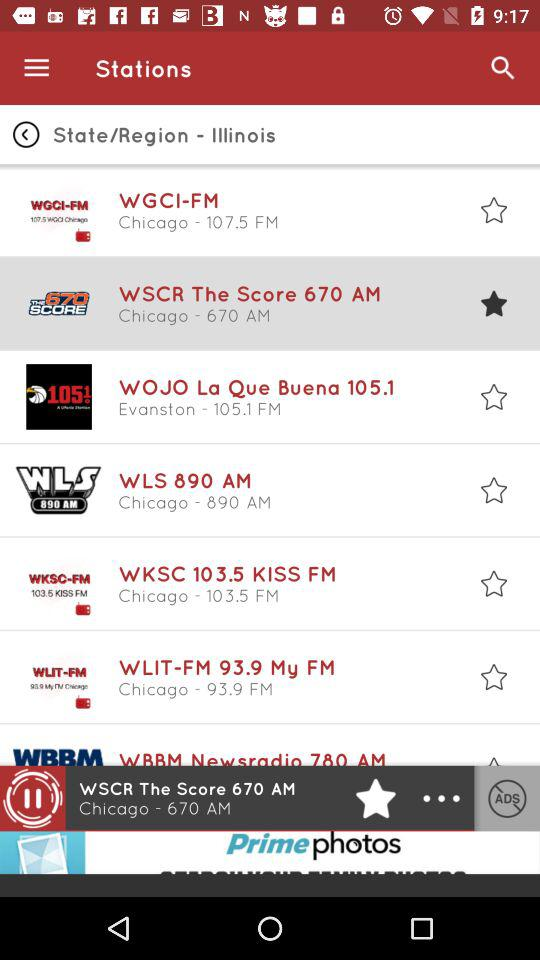What is the selected FM station? The selected FM station is "WSCR The Score 670 AM". 